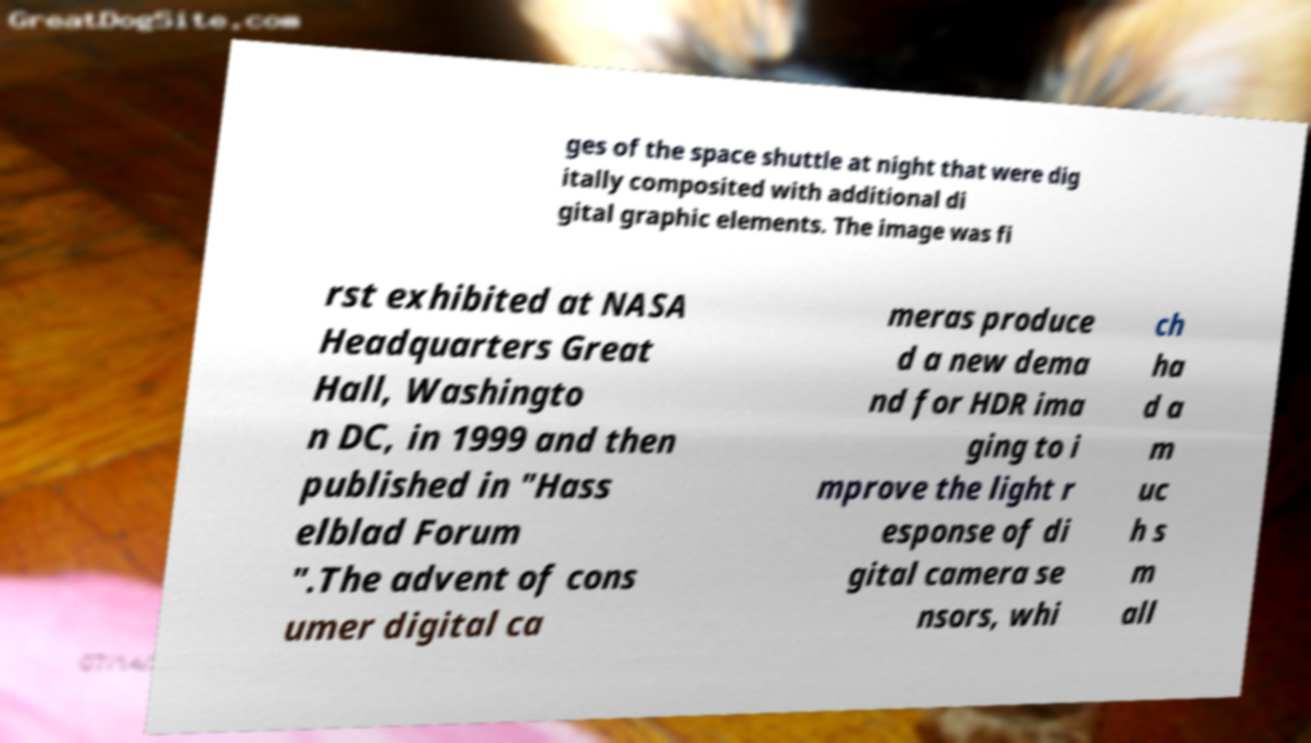Could you assist in decoding the text presented in this image and type it out clearly? ges of the space shuttle at night that were dig itally composited with additional di gital graphic elements. The image was fi rst exhibited at NASA Headquarters Great Hall, Washingto n DC, in 1999 and then published in "Hass elblad Forum ".The advent of cons umer digital ca meras produce d a new dema nd for HDR ima ging to i mprove the light r esponse of di gital camera se nsors, whi ch ha d a m uc h s m all 